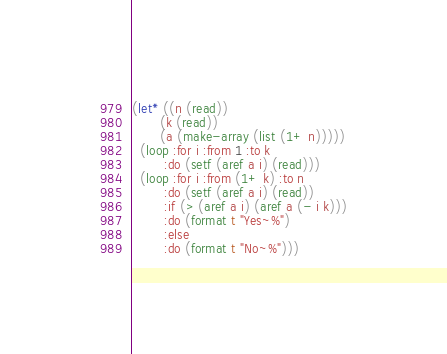<code> <loc_0><loc_0><loc_500><loc_500><_Lisp_>(let* ((n (read))
       (k (read))
       (a (make-array (list (1+ n)))))
  (loop :for i :from 1 :to k
        :do (setf (aref a i) (read)))
  (loop :for i :from (1+ k) :to n
        :do (setf (aref a i) (read))
        :if (> (aref a i) (aref a (- i k)))
        :do (format t "Yes~%")
        :else
        :do (format t "No~%")))
</code> 